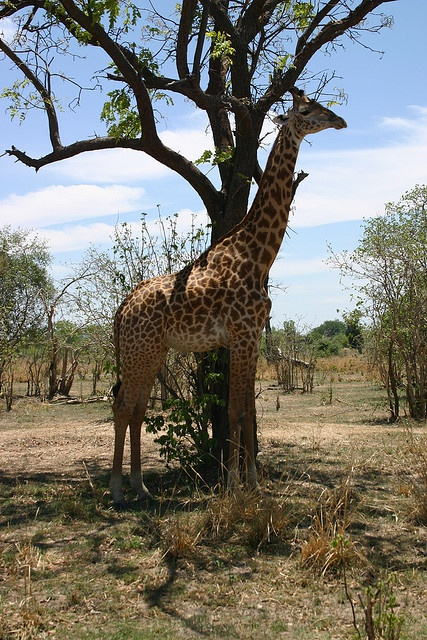Describe the objects in this image and their specific colors. I can see a giraffe in lightblue, black, maroon, and gray tones in this image. 